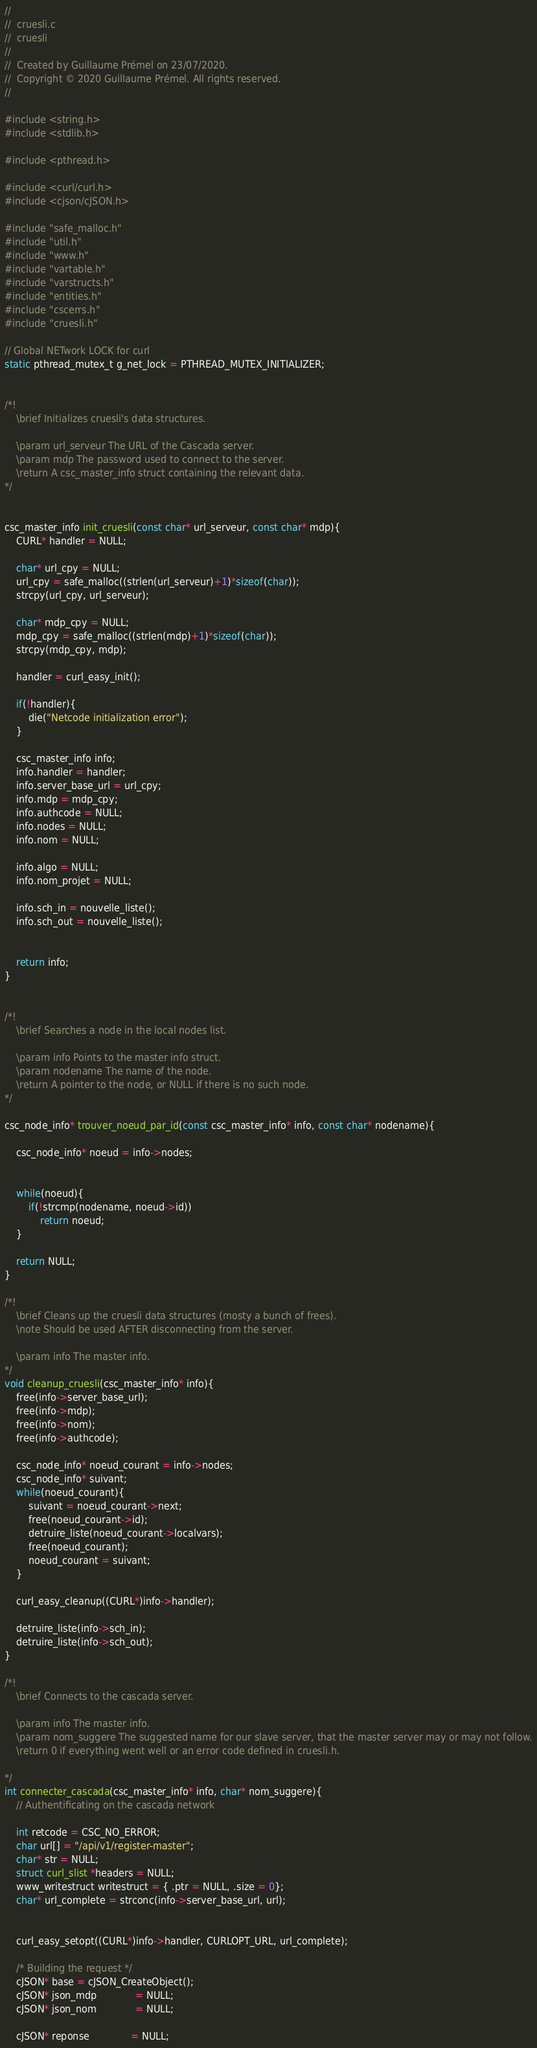<code> <loc_0><loc_0><loc_500><loc_500><_C_>//
//  cruesli.c
//  cruesli
//
//  Created by Guillaume Prémel on 23/07/2020.
//  Copyright © 2020 Guillaume Prémel. All rights reserved.
//

#include <string.h>
#include <stdlib.h>

#include <pthread.h>

#include <curl/curl.h>
#include <cjson/cJSON.h>

#include "safe_malloc.h"
#include "util.h"
#include "www.h"
#include "vartable.h"
#include "varstructs.h"
#include "entities.h"
#include "cscerrs.h"
#include "cruesli.h"

// Global NETwork LOCK for curl
static pthread_mutex_t g_net_lock = PTHREAD_MUTEX_INITIALIZER;


/*!
    \brief Initializes cruesli's data structures.
    
    \param url_serveur The URL of the Cascada server.
    \param mdp The password used to connect to the server.
    \return A csc_master_info struct containing the relevant data.
*/


csc_master_info init_cruesli(const char* url_serveur, const char* mdp){
    CURL* handler = NULL;
    
    char* url_cpy = NULL;
    url_cpy = safe_malloc((strlen(url_serveur)+1)*sizeof(char));
    strcpy(url_cpy, url_serveur);
    
    char* mdp_cpy = NULL;
    mdp_cpy = safe_malloc((strlen(mdp)+1)*sizeof(char));
    strcpy(mdp_cpy, mdp);
    
    handler = curl_easy_init();
    
    if(!handler){
        die("Netcode initialization error");
    }
    
    csc_master_info info;
    info.handler = handler;
    info.server_base_url = url_cpy;
    info.mdp = mdp_cpy;
    info.authcode = NULL;
    info.nodes = NULL;
    info.nom = NULL;
    
    info.algo = NULL;
    info.nom_projet = NULL;
    
    info.sch_in = nouvelle_liste();
    info.sch_out = nouvelle_liste();
    
    
    return info;
}


/*!
    \brief Searches a node in the local nodes list.
    
    \param info Points to the master info struct.
    \param nodename The name of the node.
    \return A pointer to the node, or NULL if there is no such node.
*/

csc_node_info* trouver_noeud_par_id(const csc_master_info* info, const char* nodename){
    
    csc_node_info* noeud = info->nodes;
    
    
    while(noeud){
        if(!strcmp(nodename, noeud->id))
            return noeud;
    }
    
    return NULL;
}

/*!
    \brief Cleans up the cruesli data structures (mosty a bunch of frees).
    \note Should be used AFTER disconnecting from the server.
    
    \param info The master info.
*/
void cleanup_cruesli(csc_master_info* info){
    free(info->server_base_url);
    free(info->mdp);
    free(info->nom);
    free(info->authcode);
    
    csc_node_info* noeud_courant = info->nodes;
    csc_node_info* suivant;
    while(noeud_courant){
        suivant = noeud_courant->next;
        free(noeud_courant->id);
        detruire_liste(noeud_courant->localvars);
        free(noeud_courant);
        noeud_courant = suivant;
    }
    
    curl_easy_cleanup((CURL*)info->handler);
    
    detruire_liste(info->sch_in);
    detruire_liste(info->sch_out);
}

/*!
    \brief Connects to the cascada server.
    
    \param info The master info.
    \param nom_suggere The suggested name for our slave server, that the master server may or may not follow.
    \return 0 if everything went well or an error code defined in cruesli.h.
                    
*/
int connecter_cascada(csc_master_info* info, char* nom_suggere){
    // Authentificating on the cascada network
    
    int retcode = CSC_NO_ERROR;
    char url[] = "/api/v1/register-master";
    char* str = NULL;
    struct curl_slist *headers = NULL;
    www_writestruct writestruct = { .ptr = NULL, .size = 0};
    char* url_complete = strconc(info->server_base_url, url);
    
    
    curl_easy_setopt((CURL*)info->handler, CURLOPT_URL, url_complete);
    
    /* Building the request */
    cJSON* base = cJSON_CreateObject();
    cJSON* json_mdp             = NULL;
    cJSON* json_nom             = NULL;
    
    cJSON* reponse              = NULL;</code> 